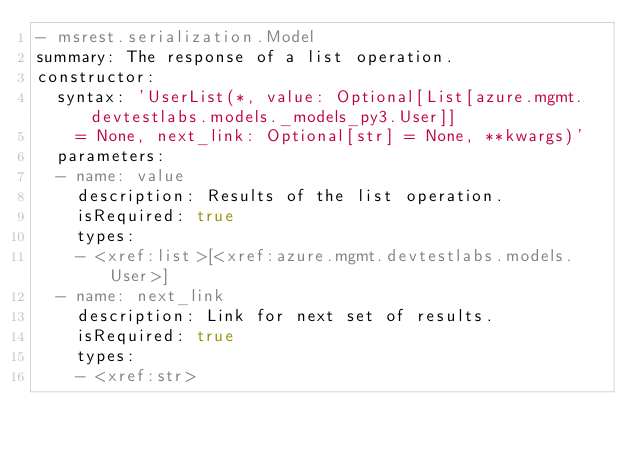<code> <loc_0><loc_0><loc_500><loc_500><_YAML_>- msrest.serialization.Model
summary: The response of a list operation.
constructor:
  syntax: 'UserList(*, value: Optional[List[azure.mgmt.devtestlabs.models._models_py3.User]]
    = None, next_link: Optional[str] = None, **kwargs)'
  parameters:
  - name: value
    description: Results of the list operation.
    isRequired: true
    types:
    - <xref:list>[<xref:azure.mgmt.devtestlabs.models.User>]
  - name: next_link
    description: Link for next set of results.
    isRequired: true
    types:
    - <xref:str>
</code> 